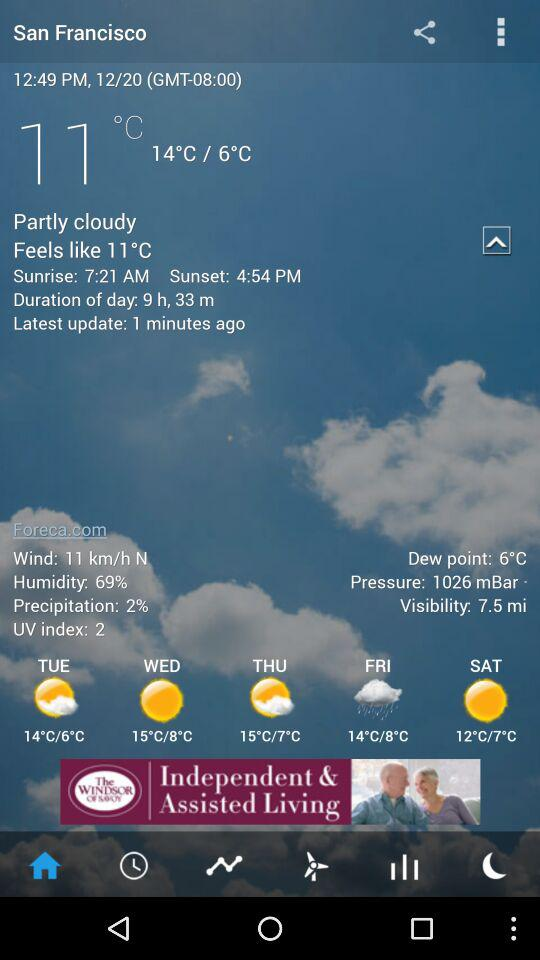What time is the sunrise? The sunrise is at 7:21 AM. 